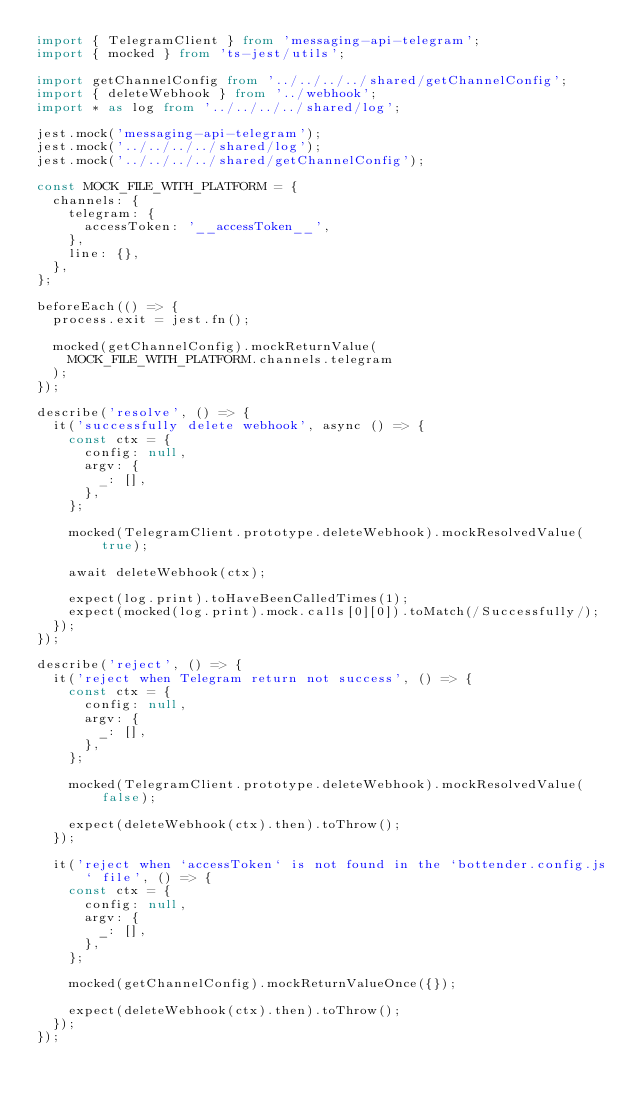<code> <loc_0><loc_0><loc_500><loc_500><_TypeScript_>import { TelegramClient } from 'messaging-api-telegram';
import { mocked } from 'ts-jest/utils';

import getChannelConfig from '../../../../shared/getChannelConfig';
import { deleteWebhook } from '../webhook';
import * as log from '../../../../shared/log';

jest.mock('messaging-api-telegram');
jest.mock('../../../../shared/log');
jest.mock('../../../../shared/getChannelConfig');

const MOCK_FILE_WITH_PLATFORM = {
  channels: {
    telegram: {
      accessToken: '__accessToken__',
    },
    line: {},
  },
};

beforeEach(() => {
  process.exit = jest.fn();

  mocked(getChannelConfig).mockReturnValue(
    MOCK_FILE_WITH_PLATFORM.channels.telegram
  );
});

describe('resolve', () => {
  it('successfully delete webhook', async () => {
    const ctx = {
      config: null,
      argv: {
        _: [],
      },
    };

    mocked(TelegramClient.prototype.deleteWebhook).mockResolvedValue(true);

    await deleteWebhook(ctx);

    expect(log.print).toHaveBeenCalledTimes(1);
    expect(mocked(log.print).mock.calls[0][0]).toMatch(/Successfully/);
  });
});

describe('reject', () => {
  it('reject when Telegram return not success', () => {
    const ctx = {
      config: null,
      argv: {
        _: [],
      },
    };

    mocked(TelegramClient.prototype.deleteWebhook).mockResolvedValue(false);

    expect(deleteWebhook(ctx).then).toThrow();
  });

  it('reject when `accessToken` is not found in the `bottender.config.js` file', () => {
    const ctx = {
      config: null,
      argv: {
        _: [],
      },
    };

    mocked(getChannelConfig).mockReturnValueOnce({});

    expect(deleteWebhook(ctx).then).toThrow();
  });
});
</code> 